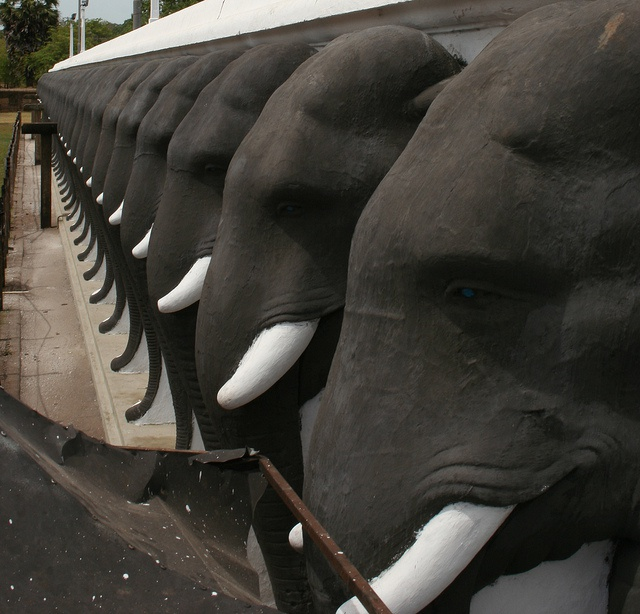Describe the objects in this image and their specific colors. I can see elephant in lightgray, black, and gray tones, elephant in lightgray, black, and gray tones, elephant in lightgray, black, and gray tones, elephant in lightgray, black, and gray tones, and elephant in lightgray, black, and gray tones in this image. 